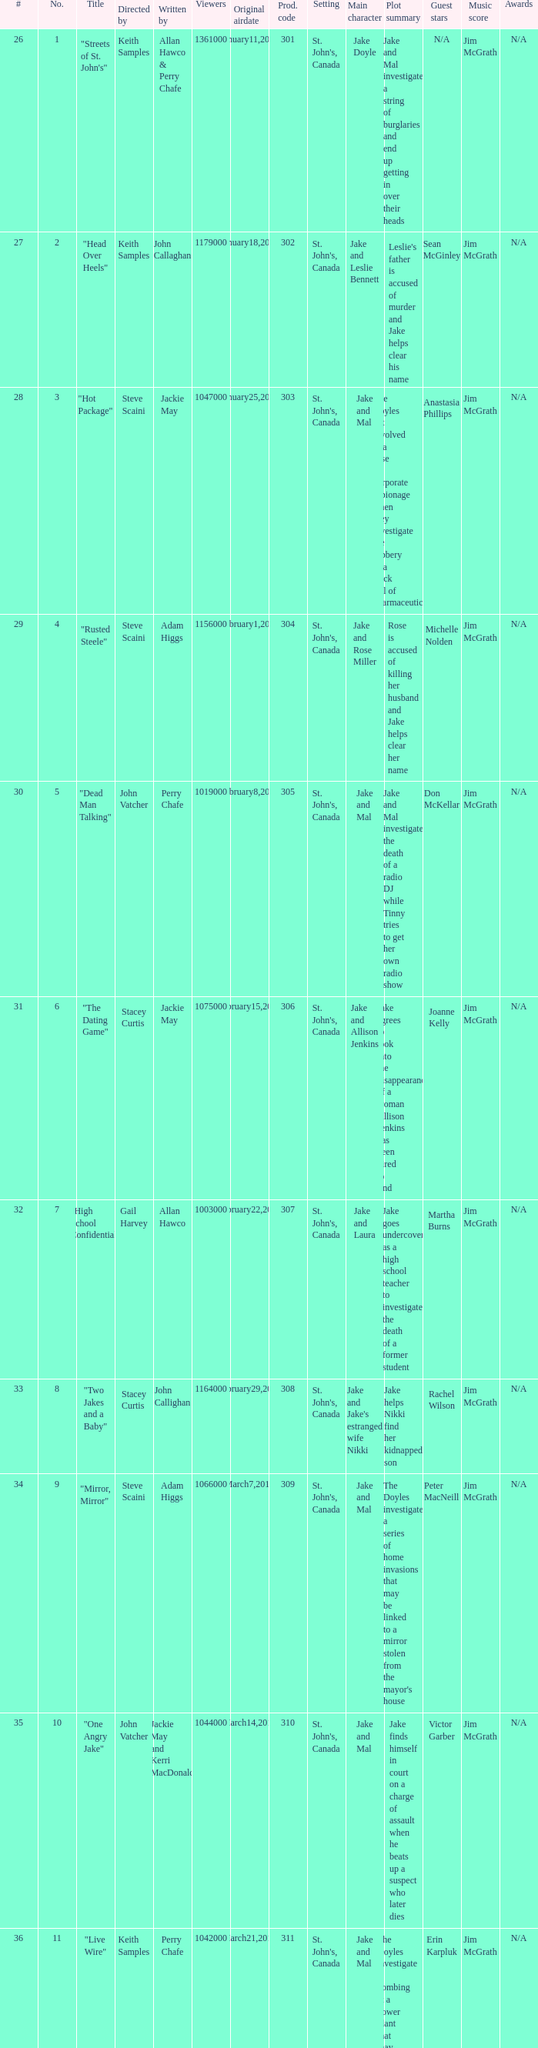What is the number of original airdate written by allan hawco? 1.0. 